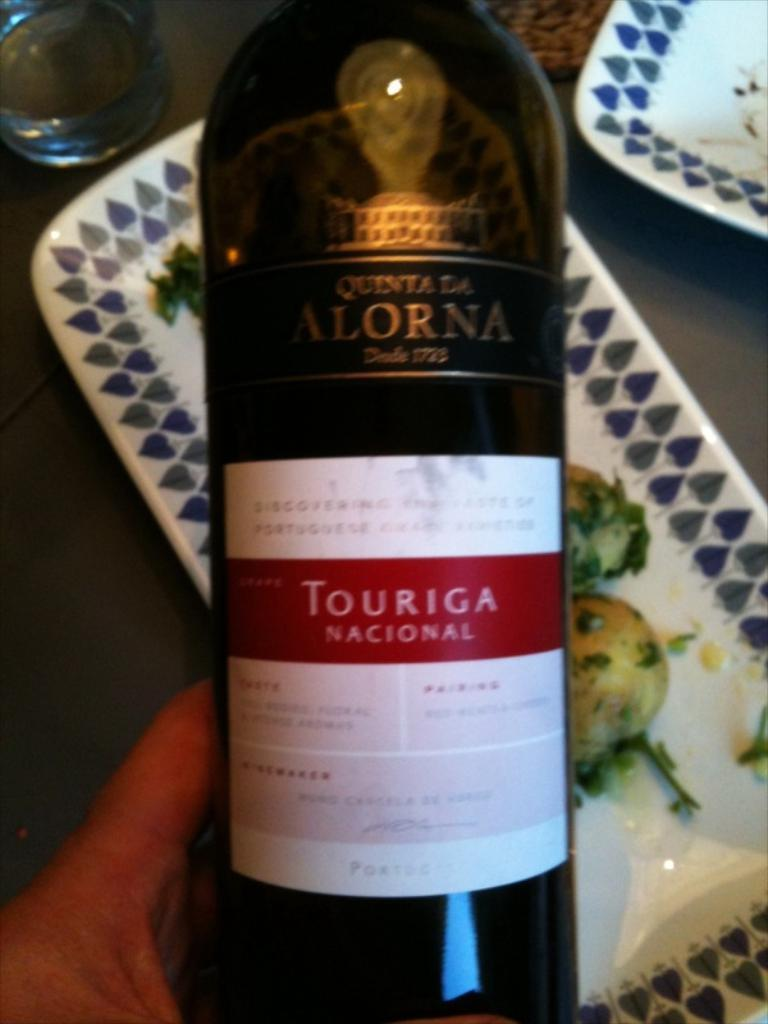Provide a one-sentence caption for the provided image. A person holds up a bottle of Touriga Nacional. 